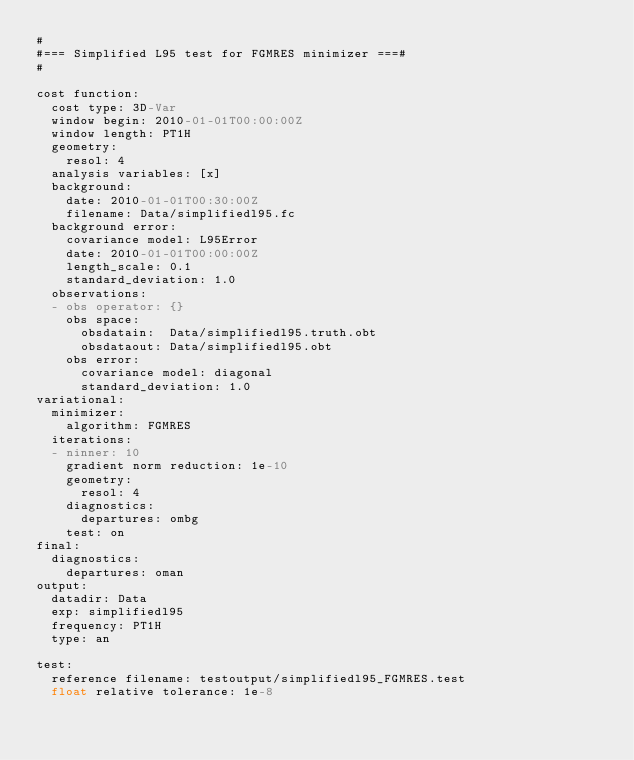Convert code to text. <code><loc_0><loc_0><loc_500><loc_500><_YAML_>#
#=== Simplified L95 test for FGMRES minimizer ===#
#

cost function:
  cost type: 3D-Var
  window begin: 2010-01-01T00:00:00Z
  window length: PT1H
  geometry:
    resol: 4
  analysis variables: [x]
  background:
    date: 2010-01-01T00:30:00Z
    filename: Data/simplifiedl95.fc
  background error:
    covariance model: L95Error
    date: 2010-01-01T00:00:00Z
    length_scale: 0.1
    standard_deviation: 1.0
  observations:
  - obs operator: {}
    obs space:
      obsdatain:  Data/simplifiedl95.truth.obt
      obsdataout: Data/simplifiedl95.obt
    obs error:
      covariance model: diagonal
      standard_deviation: 1.0
variational:
  minimizer:
    algorithm: FGMRES
  iterations:
  - ninner: 10
    gradient norm reduction: 1e-10
    geometry:
      resol: 4
    diagnostics:
      departures: ombg
    test: on
final:
  diagnostics:
    departures: oman
output:
  datadir: Data
  exp: simplifiedl95
  frequency: PT1H
  type: an

test:
  reference filename: testoutput/simplifiedl95_FGMRES.test
  float relative tolerance: 1e-8
</code> 